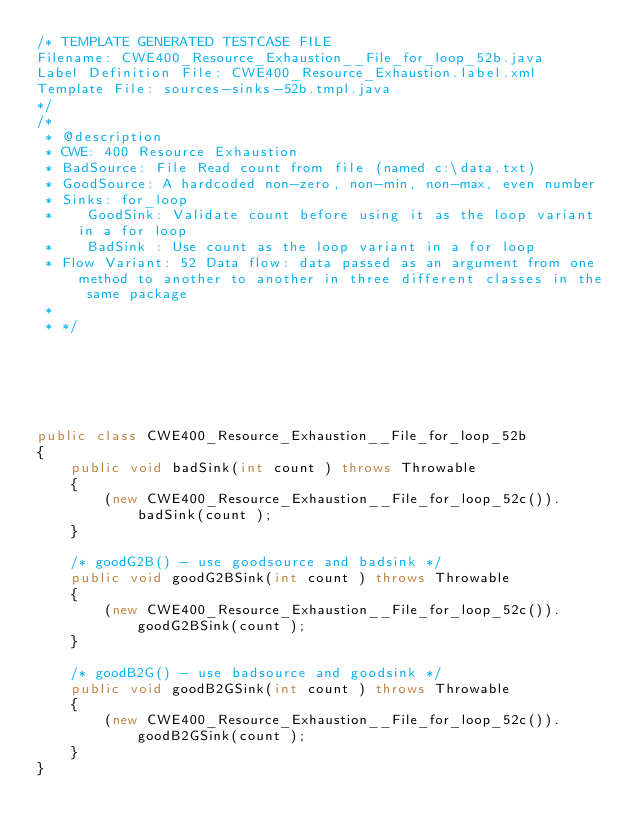Convert code to text. <code><loc_0><loc_0><loc_500><loc_500><_Java_>/* TEMPLATE GENERATED TESTCASE FILE
Filename: CWE400_Resource_Exhaustion__File_for_loop_52b.java
Label Definition File: CWE400_Resource_Exhaustion.label.xml
Template File: sources-sinks-52b.tmpl.java
*/
/*
 * @description
 * CWE: 400 Resource Exhaustion
 * BadSource: File Read count from file (named c:\data.txt)
 * GoodSource: A hardcoded non-zero, non-min, non-max, even number
 * Sinks: for_loop
 *    GoodSink: Validate count before using it as the loop variant in a for loop
 *    BadSink : Use count as the loop variant in a for loop
 * Flow Variant: 52 Data flow: data passed as an argument from one method to another to another in three different classes in the same package
 *
 * */






public class CWE400_Resource_Exhaustion__File_for_loop_52b
{
    public void badSink(int count ) throws Throwable
    {
        (new CWE400_Resource_Exhaustion__File_for_loop_52c()).badSink(count );
    }

    /* goodG2B() - use goodsource and badsink */
    public void goodG2BSink(int count ) throws Throwable
    {
        (new CWE400_Resource_Exhaustion__File_for_loop_52c()).goodG2BSink(count );
    }

    /* goodB2G() - use badsource and goodsink */
    public void goodB2GSink(int count ) throws Throwable
    {
        (new CWE400_Resource_Exhaustion__File_for_loop_52c()).goodB2GSink(count );
    }
}
</code> 